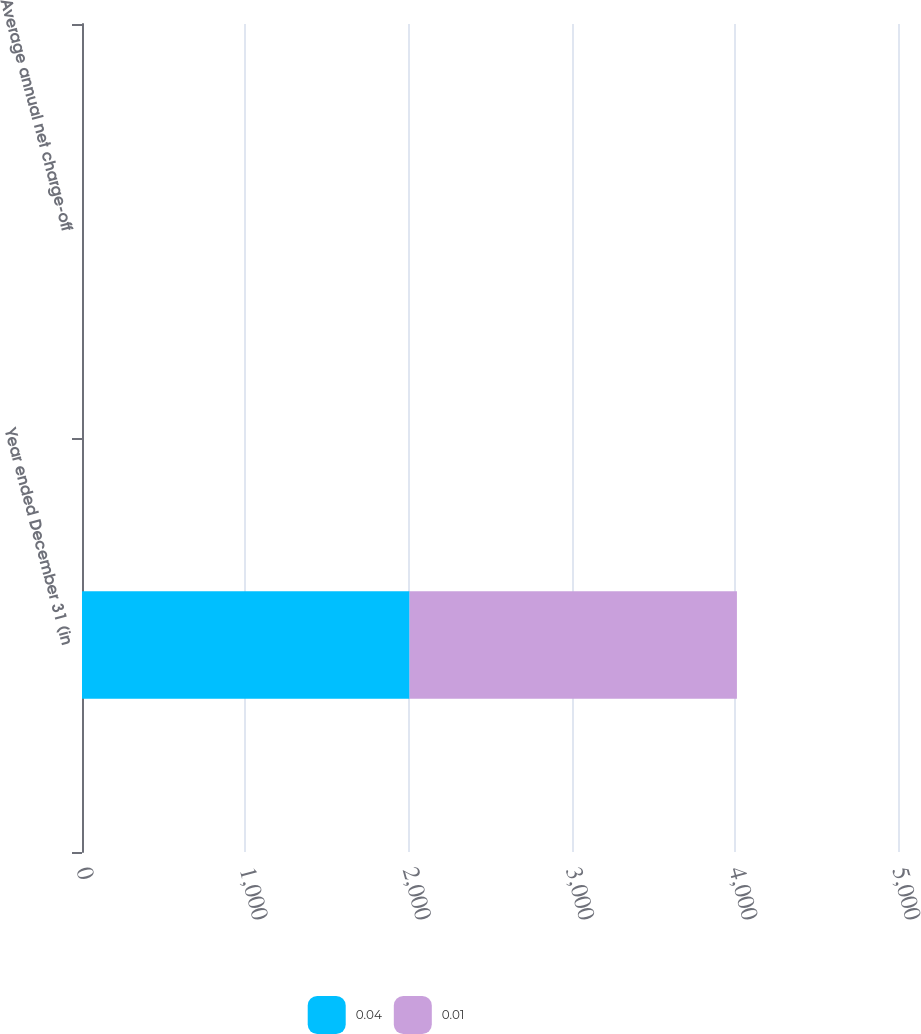<chart> <loc_0><loc_0><loc_500><loc_500><stacked_bar_chart><ecel><fcel>Year ended December 31 (in<fcel>Average annual net charge-off<nl><fcel>0.04<fcel>2007<fcel>0.04<nl><fcel>0.01<fcel>2006<fcel>0.01<nl></chart> 